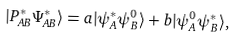<formula> <loc_0><loc_0><loc_500><loc_500>| P _ { A B } ^ { \ast } \Psi _ { A B } ^ { \ast } \rangle = a | \psi _ { A } ^ { \ast } \psi _ { B } ^ { 0 } \rangle + b | \psi _ { A } ^ { 0 } \psi _ { B } ^ { \ast } \rangle ,</formula> 